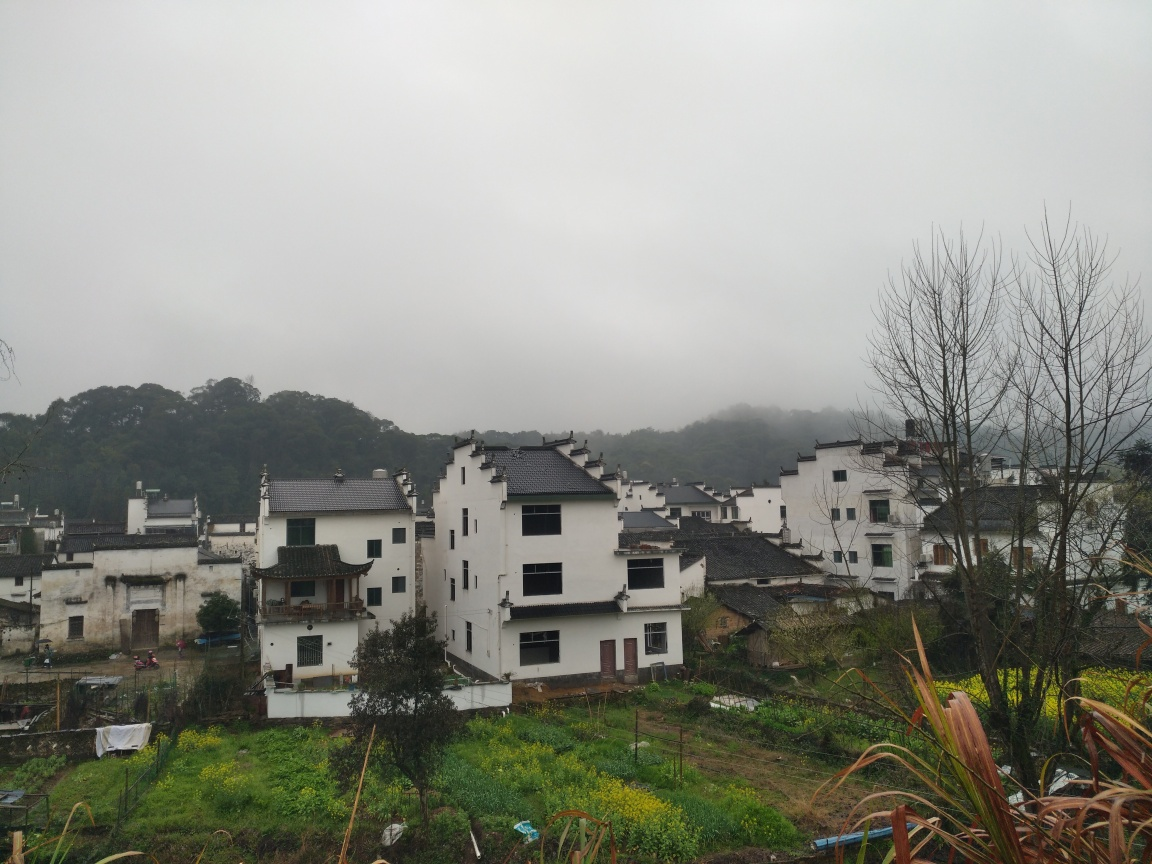How does the landscape in this photo seem to impact the architecture we see? The architecture seems to be in harmony with the sloping landscape, with buildings constructed at different levels. The design of the houses with their tiered placement likely takes advantage of the terrain for drainage and to offer stunning views of the surrounding area. The buildings are closely packed, maximizing the limited flat space available for construction in the hilly region. 